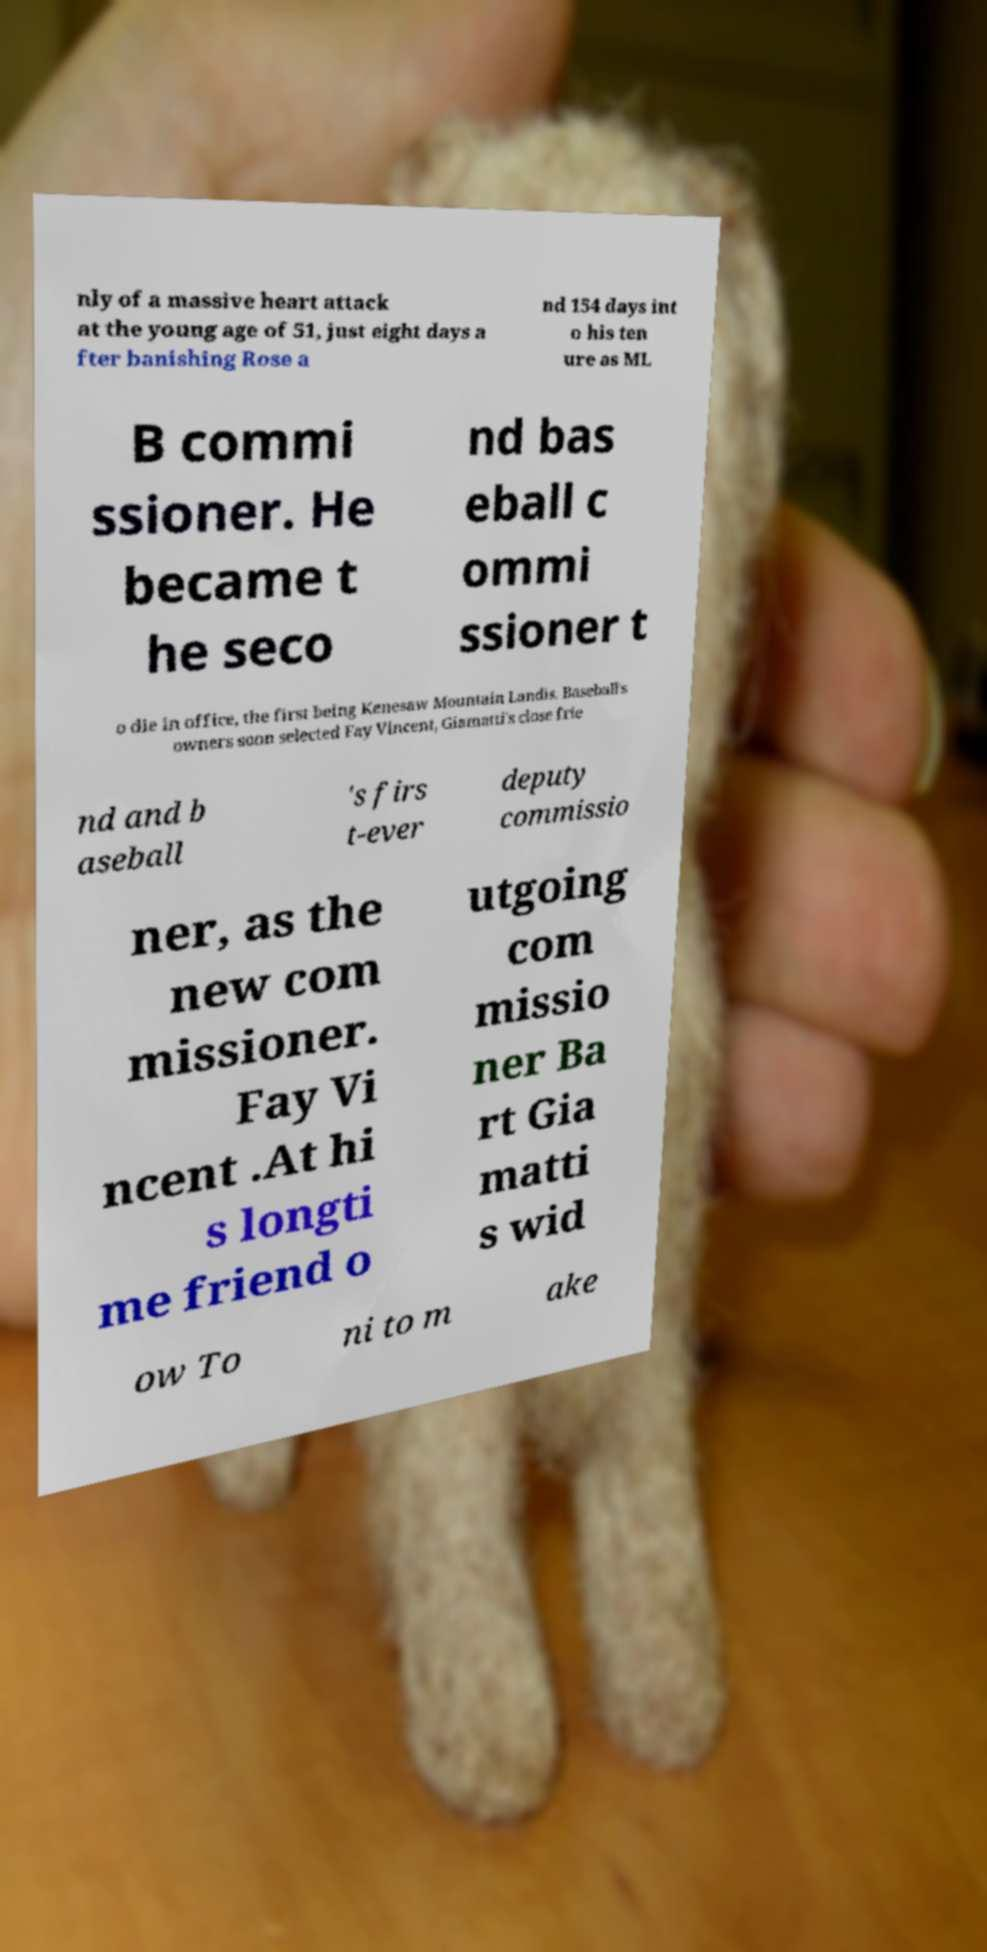Could you extract and type out the text from this image? nly of a massive heart attack at the young age of 51, just eight days a fter banishing Rose a nd 154 days int o his ten ure as ML B commi ssioner. He became t he seco nd bas eball c ommi ssioner t o die in office, the first being Kenesaw Mountain Landis. Baseball's owners soon selected Fay Vincent, Giamatti's close frie nd and b aseball 's firs t-ever deputy commissio ner, as the new com missioner. Fay Vi ncent .At hi s longti me friend o utgoing com missio ner Ba rt Gia matti s wid ow To ni to m ake 